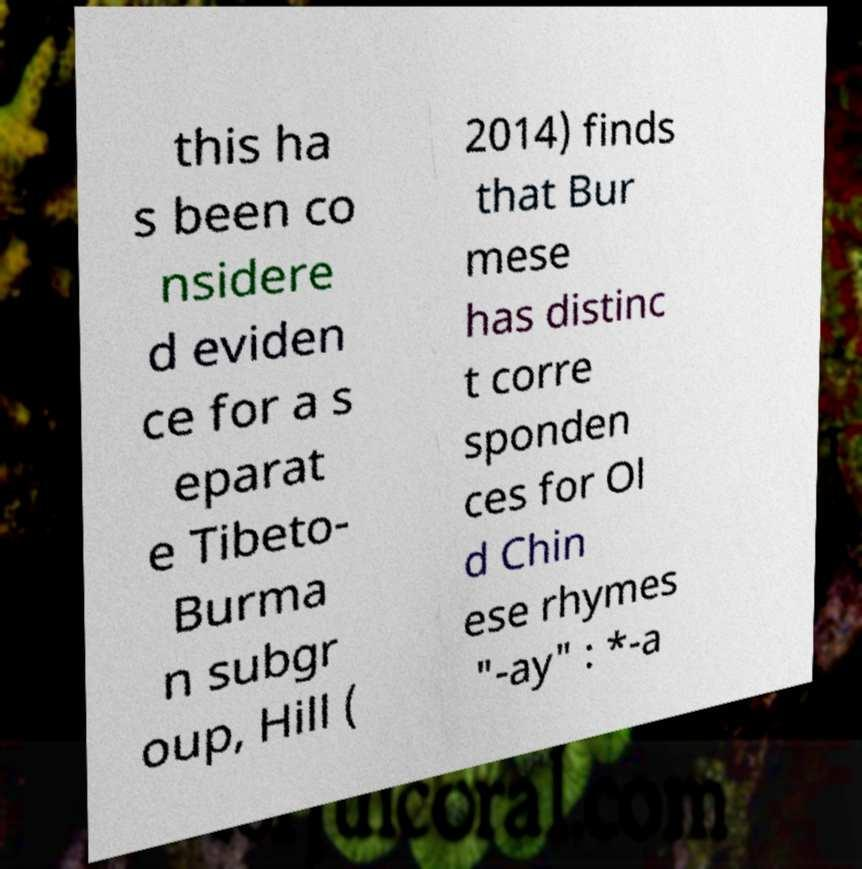What messages or text are displayed in this image? I need them in a readable, typed format. this ha s been co nsidere d eviden ce for a s eparat e Tibeto- Burma n subgr oup, Hill ( 2014) finds that Bur mese has distinc t corre sponden ces for Ol d Chin ese rhymes "-ay" : *-a 